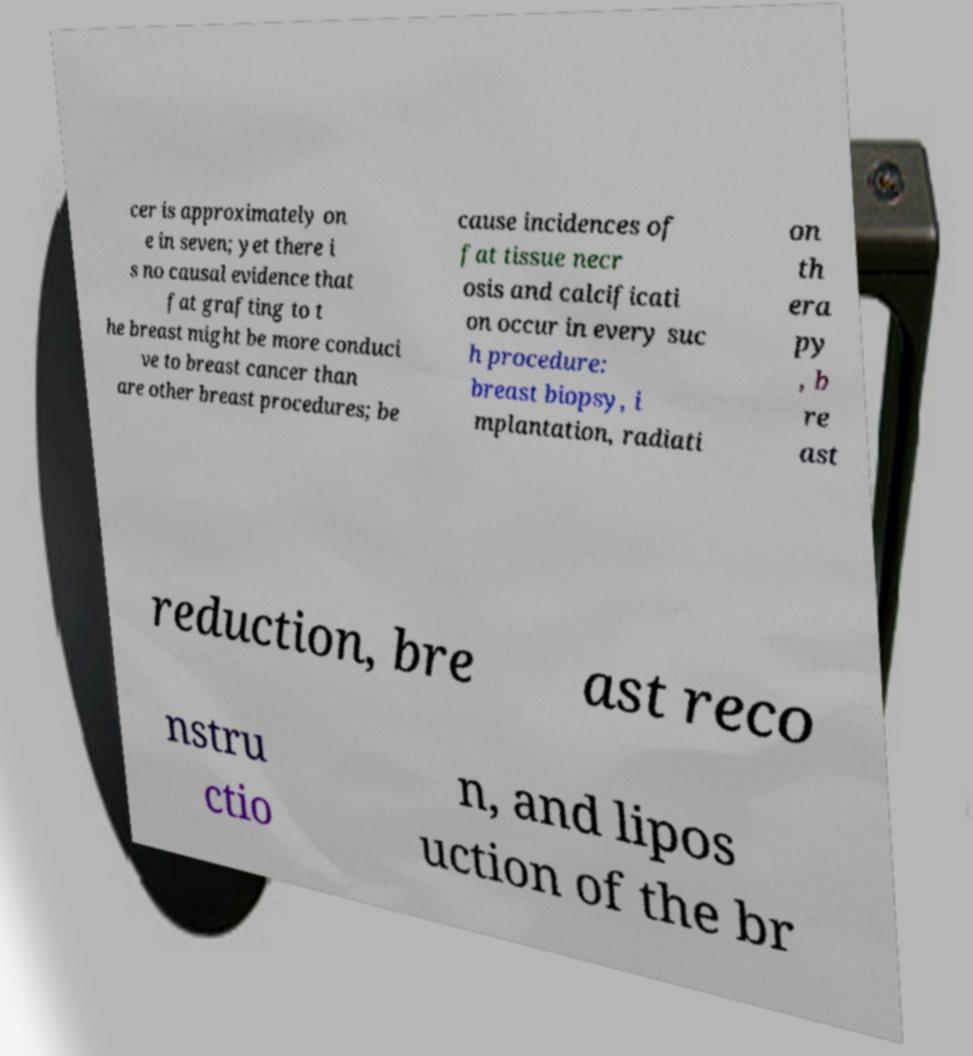For documentation purposes, I need the text within this image transcribed. Could you provide that? cer is approximately on e in seven; yet there i s no causal evidence that fat grafting to t he breast might be more conduci ve to breast cancer than are other breast procedures; be cause incidences of fat tissue necr osis and calcificati on occur in every suc h procedure: breast biopsy, i mplantation, radiati on th era py , b re ast reduction, bre ast reco nstru ctio n, and lipos uction of the br 